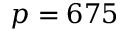<formula> <loc_0><loc_0><loc_500><loc_500>p = 6 7 5</formula> 